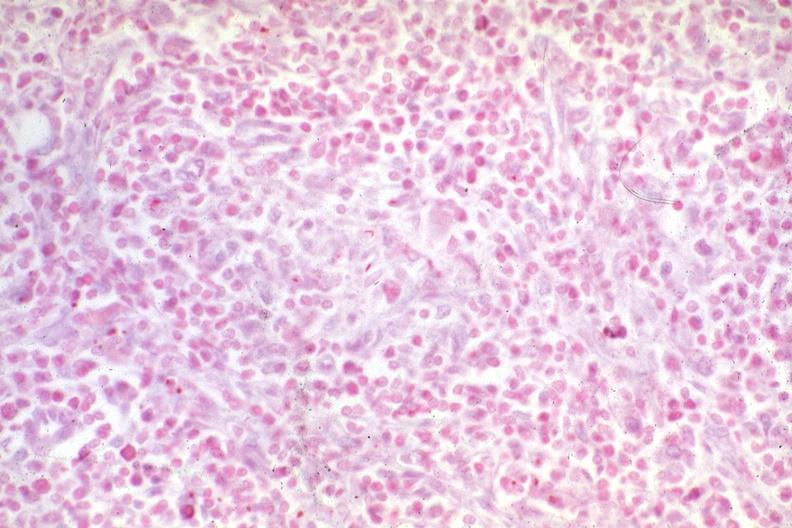s mycobacterium avium intracellulare present?
Answer the question using a single word or phrase. Yes 